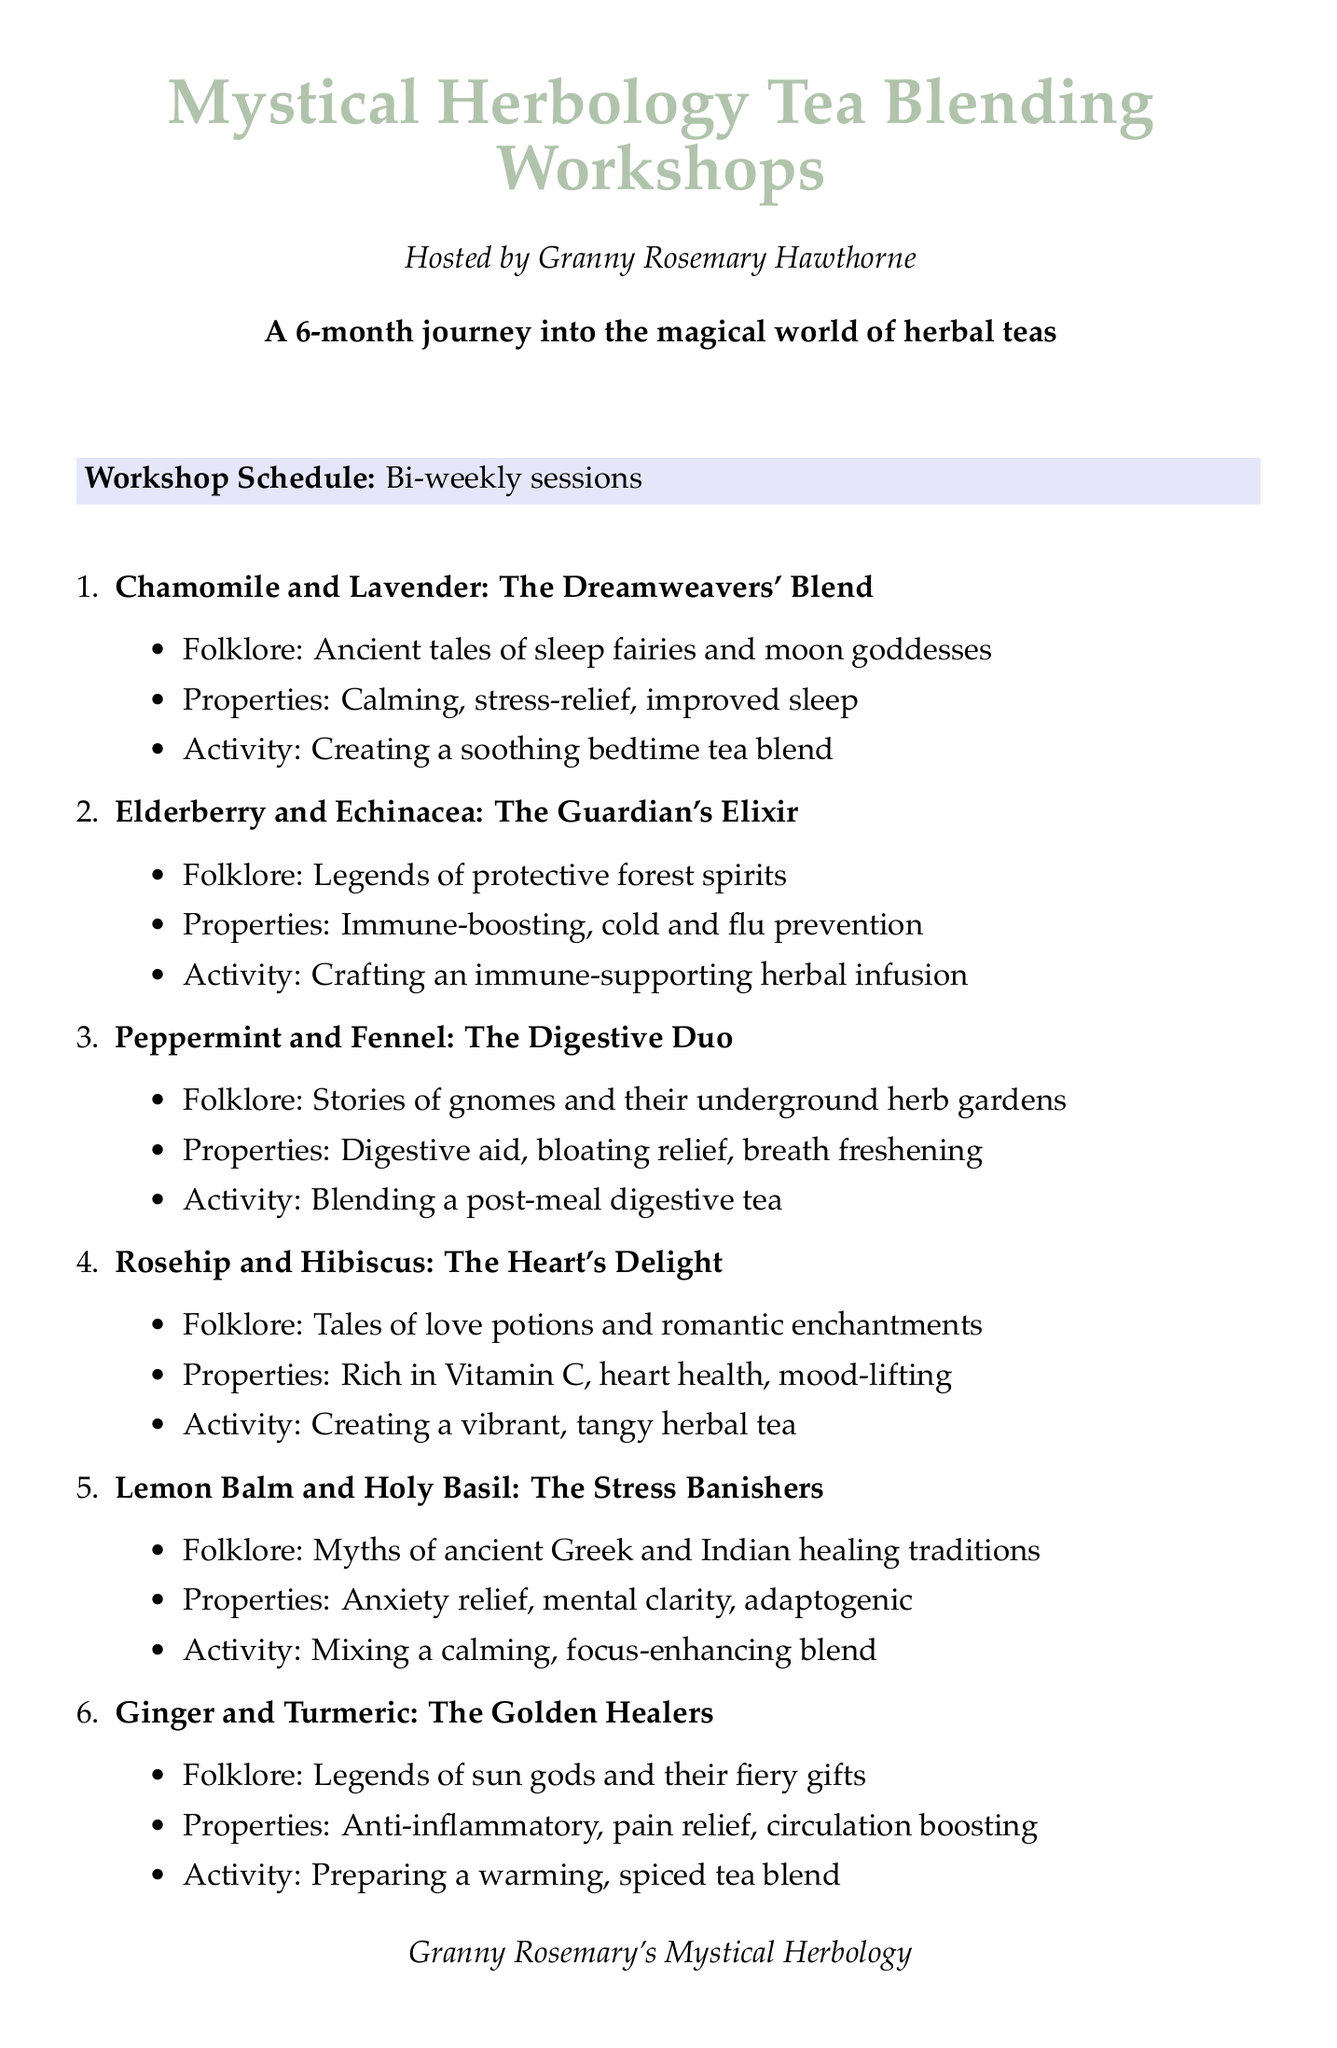What is the title of the workshop series? The title of the workshop series is provided in the document as "Mystical Herbology Tea Blending Workshops."
Answer: Mystical Herbology Tea Blending Workshops Who is hosting the workshops? The document states that the workshops are hosted by Granny Rosemary Hawthorne.
Answer: Granny Rosemary Hawthorne How many sessions are listed in the workshop schedule? The document lists twelve sessions of herbal tea blends in the workshop schedule.
Answer: 12 What is the folklore associated with Chamomile and Lavender? The folklore for Chamomile and Lavender is mentioned as "Ancient tales of sleep fairies and moon goddesses."
Answer: Ancient tales of sleep fairies and moon goddesses Which two herbs are combined to create "The Guardian's Elixir"? The document indicates that Elderberry and Echinacea are the two herbs combined for "The Guardian's Elixir."
Answer: Elderberry and Echinacea What type of support does the blend with Nettle and Red Clover provide? According to the document, the blend with Nettle and Red Clover provides detoxifying and nutrient-rich support.
Answer: Detoxifying, nutrient-rich Which additional activity involves the local botanical garden? The document specifies that "Herb identification walks in the local botanical garden" is one of the additional activities.
Answer: Herb identification walks in the local botanical garden What materials are needed for creating tea blends? The document outlines a list of materials needed, including "Various dried herbs and flowers" for blending tea.
Answer: Various dried herbs and flowers What is the duration of the workshop series? The document states that the duration of the workshop series is 6 months.
Answer: 6 months 